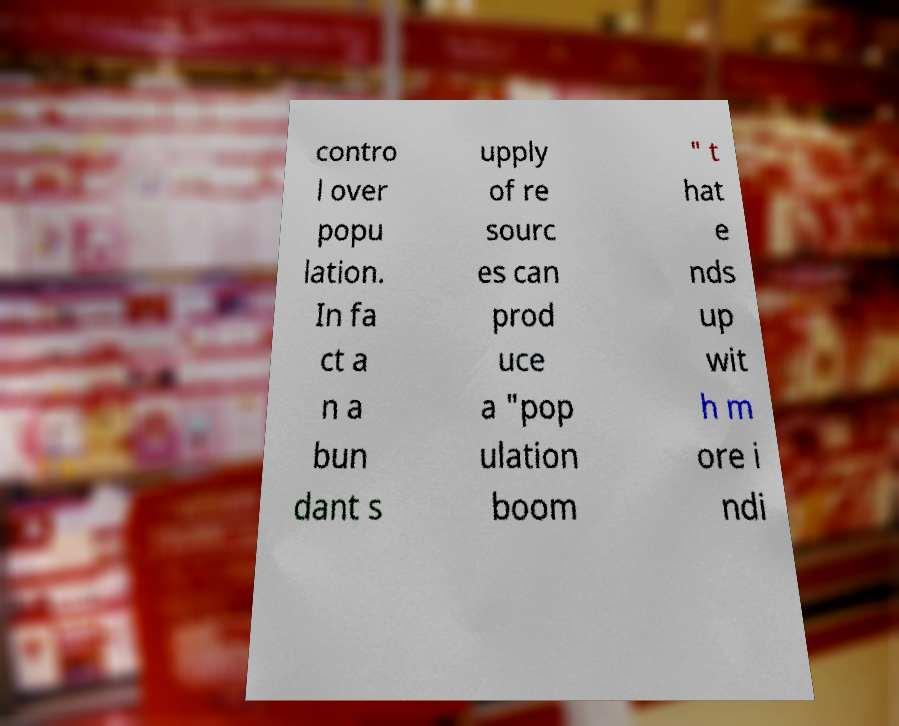Can you read and provide the text displayed in the image?This photo seems to have some interesting text. Can you extract and type it out for me? contro l over popu lation. In fa ct a n a bun dant s upply of re sourc es can prod uce a "pop ulation boom " t hat e nds up wit h m ore i ndi 